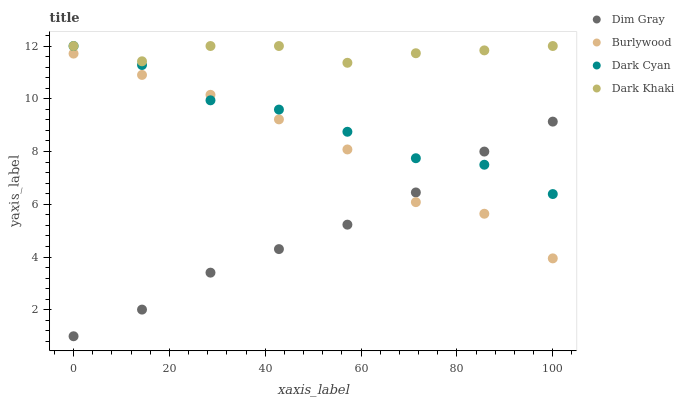Does Dim Gray have the minimum area under the curve?
Answer yes or no. Yes. Does Dark Khaki have the maximum area under the curve?
Answer yes or no. Yes. Does Dark Cyan have the minimum area under the curve?
Answer yes or no. No. Does Dark Cyan have the maximum area under the curve?
Answer yes or no. No. Is Dim Gray the smoothest?
Answer yes or no. Yes. Is Burlywood the roughest?
Answer yes or no. Yes. Is Dark Cyan the smoothest?
Answer yes or no. No. Is Dark Cyan the roughest?
Answer yes or no. No. Does Dim Gray have the lowest value?
Answer yes or no. Yes. Does Dark Cyan have the lowest value?
Answer yes or no. No. Does Dark Khaki have the highest value?
Answer yes or no. Yes. Does Dim Gray have the highest value?
Answer yes or no. No. Is Burlywood less than Dark Khaki?
Answer yes or no. Yes. Is Dark Khaki greater than Dim Gray?
Answer yes or no. Yes. Does Dark Khaki intersect Dark Cyan?
Answer yes or no. Yes. Is Dark Khaki less than Dark Cyan?
Answer yes or no. No. Is Dark Khaki greater than Dark Cyan?
Answer yes or no. No. Does Burlywood intersect Dark Khaki?
Answer yes or no. No. 